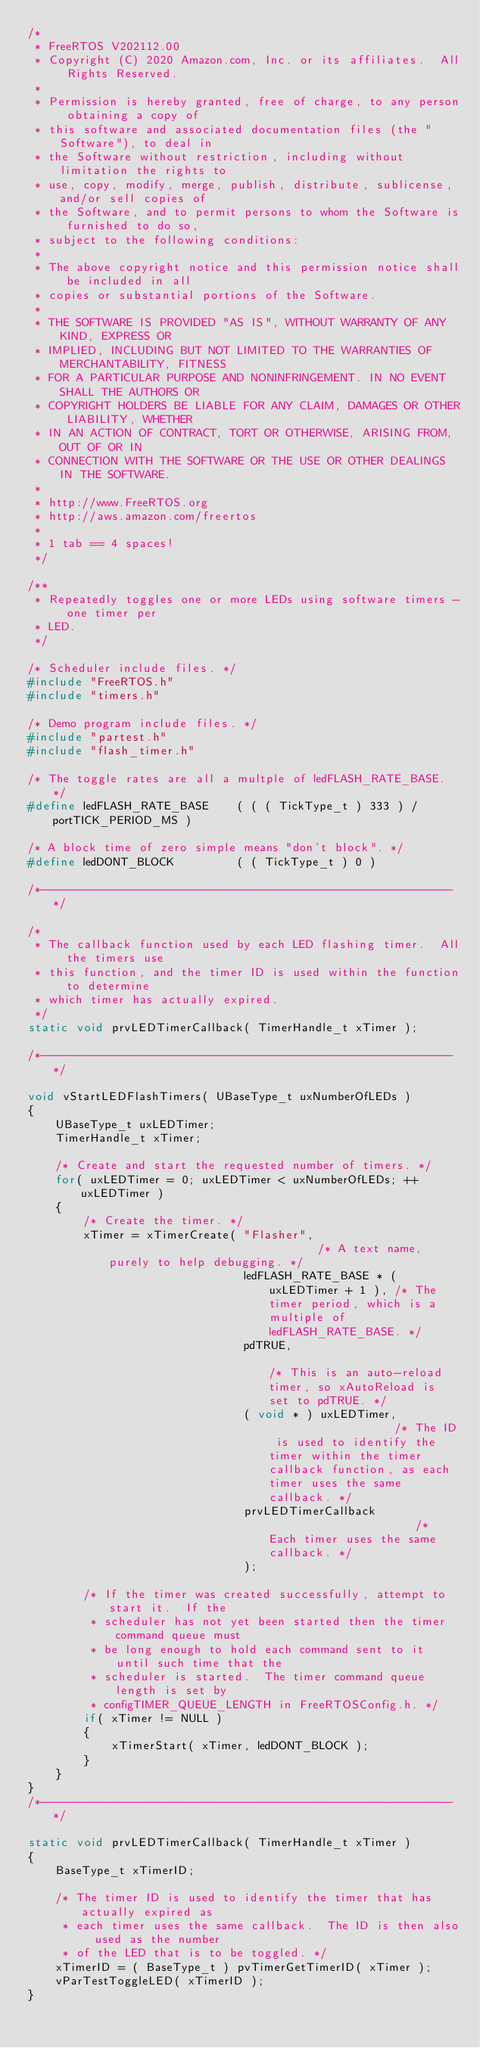<code> <loc_0><loc_0><loc_500><loc_500><_C_>/*
 * FreeRTOS V202112.00
 * Copyright (C) 2020 Amazon.com, Inc. or its affiliates.  All Rights Reserved.
 *
 * Permission is hereby granted, free of charge, to any person obtaining a copy of
 * this software and associated documentation files (the "Software"), to deal in
 * the Software without restriction, including without limitation the rights to
 * use, copy, modify, merge, publish, distribute, sublicense, and/or sell copies of
 * the Software, and to permit persons to whom the Software is furnished to do so,
 * subject to the following conditions:
 *
 * The above copyright notice and this permission notice shall be included in all
 * copies or substantial portions of the Software.
 *
 * THE SOFTWARE IS PROVIDED "AS IS", WITHOUT WARRANTY OF ANY KIND, EXPRESS OR
 * IMPLIED, INCLUDING BUT NOT LIMITED TO THE WARRANTIES OF MERCHANTABILITY, FITNESS
 * FOR A PARTICULAR PURPOSE AND NONINFRINGEMENT. IN NO EVENT SHALL THE AUTHORS OR
 * COPYRIGHT HOLDERS BE LIABLE FOR ANY CLAIM, DAMAGES OR OTHER LIABILITY, WHETHER
 * IN AN ACTION OF CONTRACT, TORT OR OTHERWISE, ARISING FROM, OUT OF OR IN
 * CONNECTION WITH THE SOFTWARE OR THE USE OR OTHER DEALINGS IN THE SOFTWARE.
 *
 * http://www.FreeRTOS.org
 * http://aws.amazon.com/freertos
 *
 * 1 tab == 4 spaces!
 */

/**
 * Repeatedly toggles one or more LEDs using software timers - one timer per
 * LED.
 */

/* Scheduler include files. */
#include "FreeRTOS.h"
#include "timers.h"

/* Demo program include files. */
#include "partest.h"
#include "flash_timer.h"

/* The toggle rates are all a multple of ledFLASH_RATE_BASE. */
#define ledFLASH_RATE_BASE    ( ( ( TickType_t ) 333 ) / portTICK_PERIOD_MS )

/* A block time of zero simple means "don't block". */
#define ledDONT_BLOCK         ( ( TickType_t ) 0 )

/*-----------------------------------------------------------*/

/*
 * The callback function used by each LED flashing timer.  All the timers use
 * this function, and the timer ID is used within the function to determine
 * which timer has actually expired.
 */
static void prvLEDTimerCallback( TimerHandle_t xTimer );

/*-----------------------------------------------------------*/

void vStartLEDFlashTimers( UBaseType_t uxNumberOfLEDs )
{
    UBaseType_t uxLEDTimer;
    TimerHandle_t xTimer;

    /* Create and start the requested number of timers. */
    for( uxLEDTimer = 0; uxLEDTimer < uxNumberOfLEDs; ++uxLEDTimer )
    {
        /* Create the timer. */
        xTimer = xTimerCreate( "Flasher",                               /* A text name, purely to help debugging. */
                               ledFLASH_RATE_BASE * ( uxLEDTimer + 1 ), /* The timer period, which is a multiple of ledFLASH_RATE_BASE. */
                               pdTRUE,                                  /* This is an auto-reload timer, so xAutoReload is set to pdTRUE. */
                               ( void * ) uxLEDTimer,                   /* The ID is used to identify the timer within the timer callback function, as each timer uses the same callback. */
                               prvLEDTimerCallback                      /* Each timer uses the same callback. */
                               );

        /* If the timer was created successfully, attempt to start it.  If the
         * scheduler has not yet been started then the timer command queue must
         * be long enough to hold each command sent to it until such time that the
         * scheduler is started.  The timer command queue length is set by
         * configTIMER_QUEUE_LENGTH in FreeRTOSConfig.h. */
        if( xTimer != NULL )
        {
            xTimerStart( xTimer, ledDONT_BLOCK );
        }
    }
}
/*-----------------------------------------------------------*/

static void prvLEDTimerCallback( TimerHandle_t xTimer )
{
    BaseType_t xTimerID;

    /* The timer ID is used to identify the timer that has actually expired as
     * each timer uses the same callback.  The ID is then also used as the number
     * of the LED that is to be toggled. */
    xTimerID = ( BaseType_t ) pvTimerGetTimerID( xTimer );
    vParTestToggleLED( xTimerID );
}
</code> 